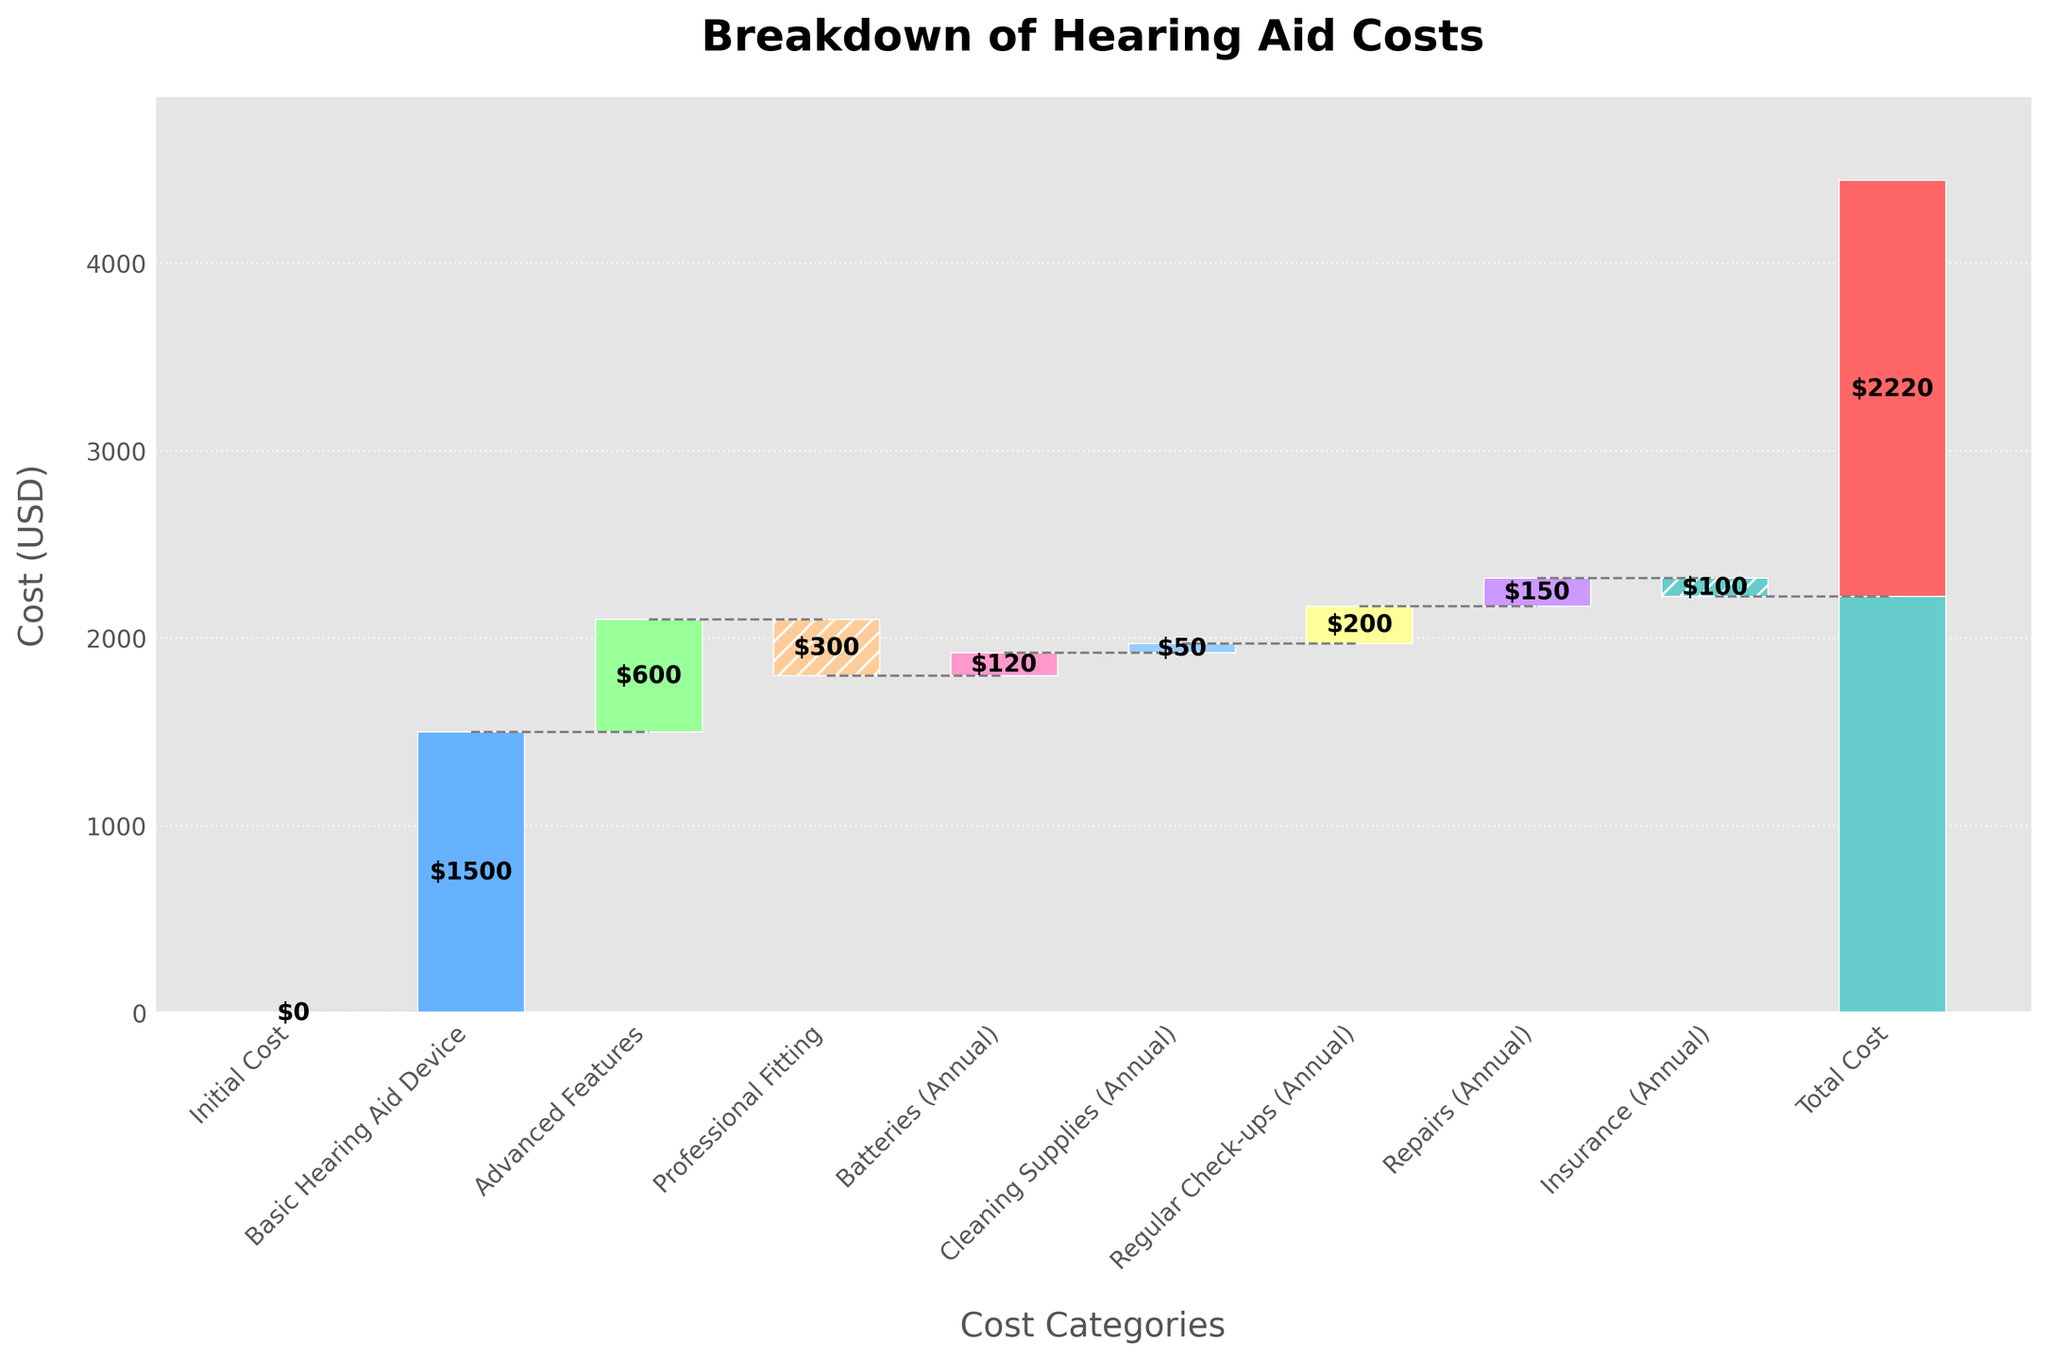What is the title of the chart? The title is displayed at the top of the chart, which clearly states what the chart is about. It helps quickly identify the content and focus of the visual representation.
Answer: Breakdown of Hearing Aid Costs What is the cost of the Basic Hearing Aid Device? The value for the Basic Hearing Aid Device is shown on the corresponding bar in the waterfall chart, clearly marked as $1500.
Answer: $1500 Which category has the highest annual cost? By comparing the heights of the bars related to annual costs (Batteries, Cleaning Supplies, Regular Check-ups, Repairs, and Insurance), Regular Check-ups stands out as the highest.
Answer: Regular Check-ups How much is the total cost indicated in the chart? The final cumulative value at the rightmost bar, labeled as Total Cost, represents the sum of all costs and credits presented in the chart.
Answer: $2220 What is the cost difference between Advanced Features and Professional Fitting? The Advanced Features cost is $600, and the Professional Fitting cost is -$300. The difference is calculated as $600 - (-$300).
Answer: $900 How do Insurance costs affect the total cost? The Insurance (Annual) bar has a negative value ($-100), indicating it subtracts from the overall total cost, reducing it by that amount.
Answer: Reduces by $100 What is the cumulative cost after including Advanced Features? The bar for Advanced Features adds $600 to the previous cumulative cost of $1500 from the Basic Hearing Aid Device, making it $1500 + $600.
Answer: $2100 How many cost categories are included in the chart? Counting the number of unique bars, excluding the initial cost and the total cost helps determine the total categories presented.
Answer: 9 What color is used for representing the total cost? The total cost bar is distinctly colored to stand out; it is shaded in a light blue color.
Answer: Light blue Which category decreases the total cost the most? Among the categories with negative values, Professional Fitting at -$300 impacts the total cost most significantly.
Answer: Professional Fitting 